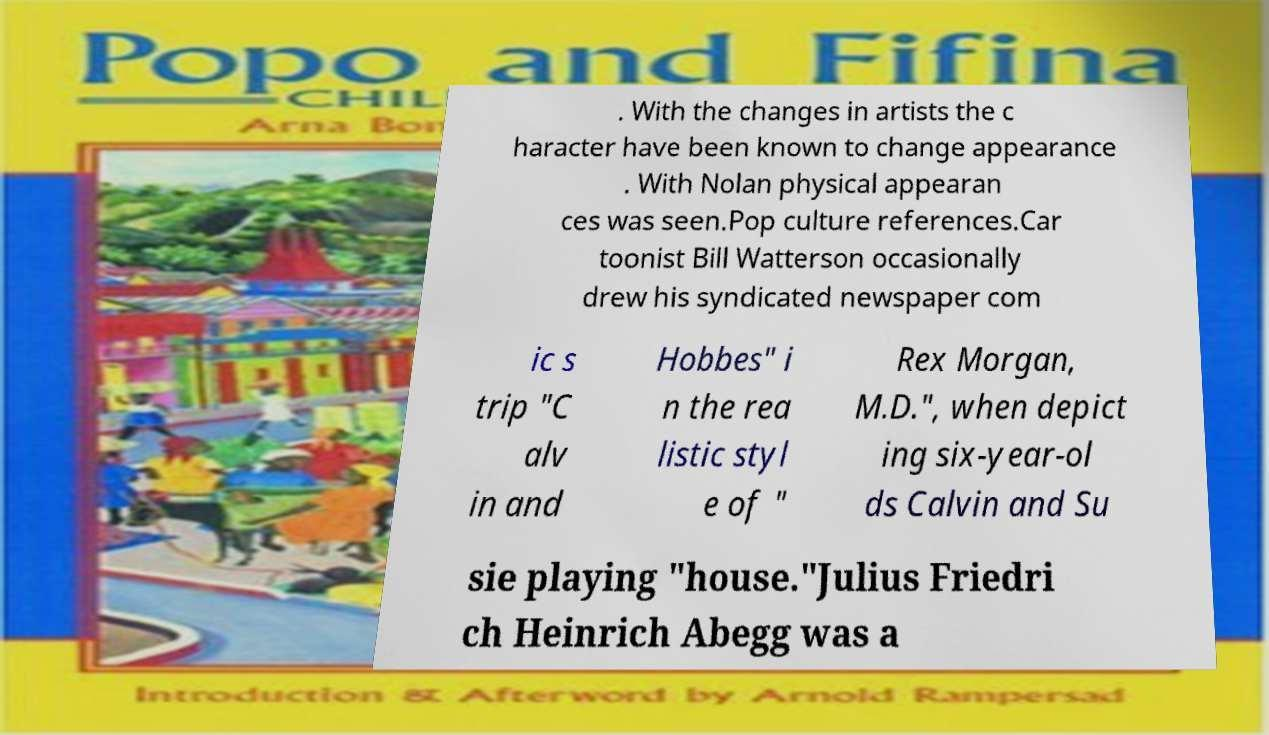Can you read and provide the text displayed in the image?This photo seems to have some interesting text. Can you extract and type it out for me? . With the changes in artists the c haracter have been known to change appearance . With Nolan physical appearan ces was seen.Pop culture references.Car toonist Bill Watterson occasionally drew his syndicated newspaper com ic s trip "C alv in and Hobbes" i n the rea listic styl e of " Rex Morgan, M.D.", when depict ing six-year-ol ds Calvin and Su sie playing "house."Julius Friedri ch Heinrich Abegg was a 